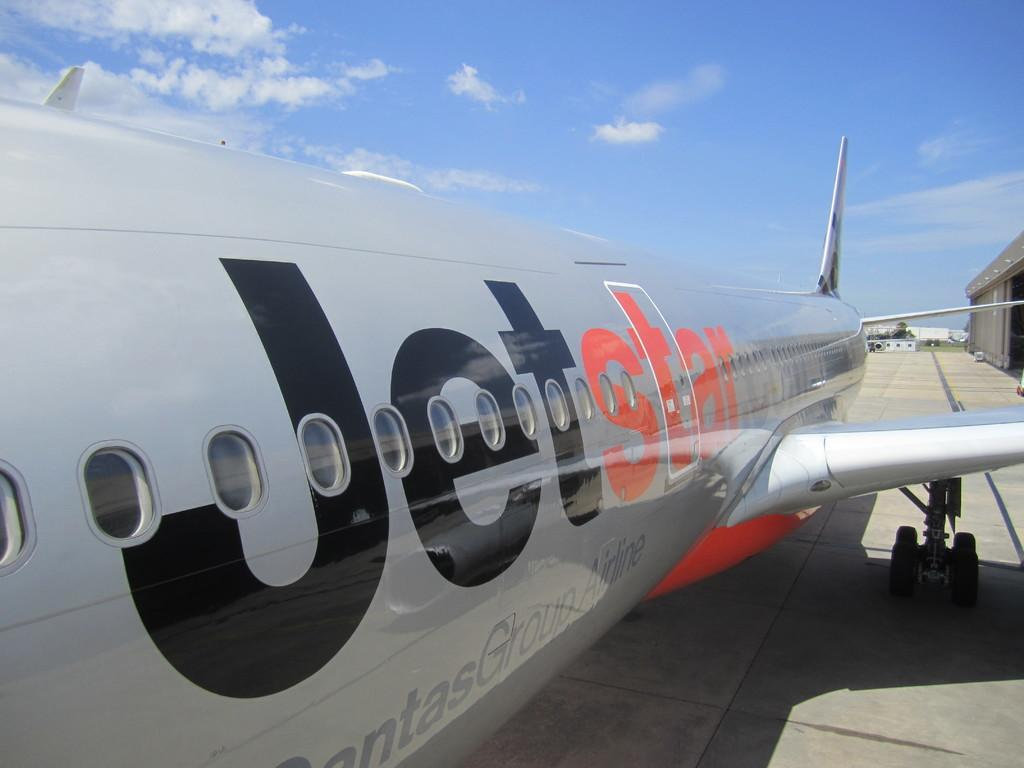<image>
Render a clear and concise summary of the photo. A Jetstar plane sits on the pavement during a sunny day. 